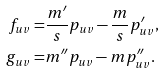<formula> <loc_0><loc_0><loc_500><loc_500>f _ { u v } = & \frac { m ^ { \prime } } { s } p _ { u v } - \frac { m } { s } p _ { u v } ^ { \prime } , \\ g _ { u v } = & m ^ { \prime \prime } p _ { u v } - m p _ { u v } ^ { \prime \prime } .</formula> 